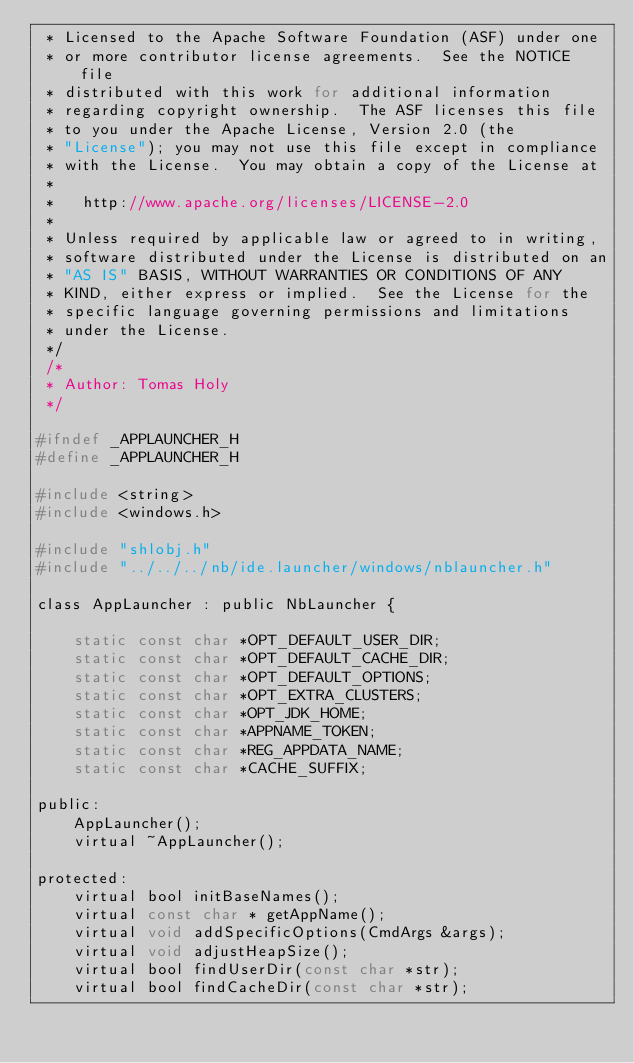<code> <loc_0><loc_0><loc_500><loc_500><_C_> * Licensed to the Apache Software Foundation (ASF) under one
 * or more contributor license agreements.  See the NOTICE file
 * distributed with this work for additional information
 * regarding copyright ownership.  The ASF licenses this file
 * to you under the Apache License, Version 2.0 (the
 * "License"); you may not use this file except in compliance
 * with the License.  You may obtain a copy of the License at
 *
 *   http://www.apache.org/licenses/LICENSE-2.0
 *
 * Unless required by applicable law or agreed to in writing,
 * software distributed under the License is distributed on an
 * "AS IS" BASIS, WITHOUT WARRANTIES OR CONDITIONS OF ANY
 * KIND, either express or implied.  See the License for the
 * specific language governing permissions and limitations
 * under the License.
 */
 /*
 * Author: Tomas Holy
 */

#ifndef _APPLAUNCHER_H
#define	_APPLAUNCHER_H

#include <string>
#include <windows.h>

#include "shlobj.h"
#include "../../../nb/ide.launcher/windows/nblauncher.h"

class AppLauncher : public NbLauncher {

    static const char *OPT_DEFAULT_USER_DIR;
    static const char *OPT_DEFAULT_CACHE_DIR;
    static const char *OPT_DEFAULT_OPTIONS;
    static const char *OPT_EXTRA_CLUSTERS;
    static const char *OPT_JDK_HOME;
    static const char *APPNAME_TOKEN;
    static const char *REG_APPDATA_NAME;
    static const char *CACHE_SUFFIX;

public:
    AppLauncher();
    virtual ~AppLauncher();

protected:
    virtual bool initBaseNames();
    virtual const char * getAppName();
    virtual void addSpecificOptions(CmdArgs &args);
    virtual void adjustHeapSize();
    virtual bool findUserDir(const char *str);
    virtual bool findCacheDir(const char *str);</code> 